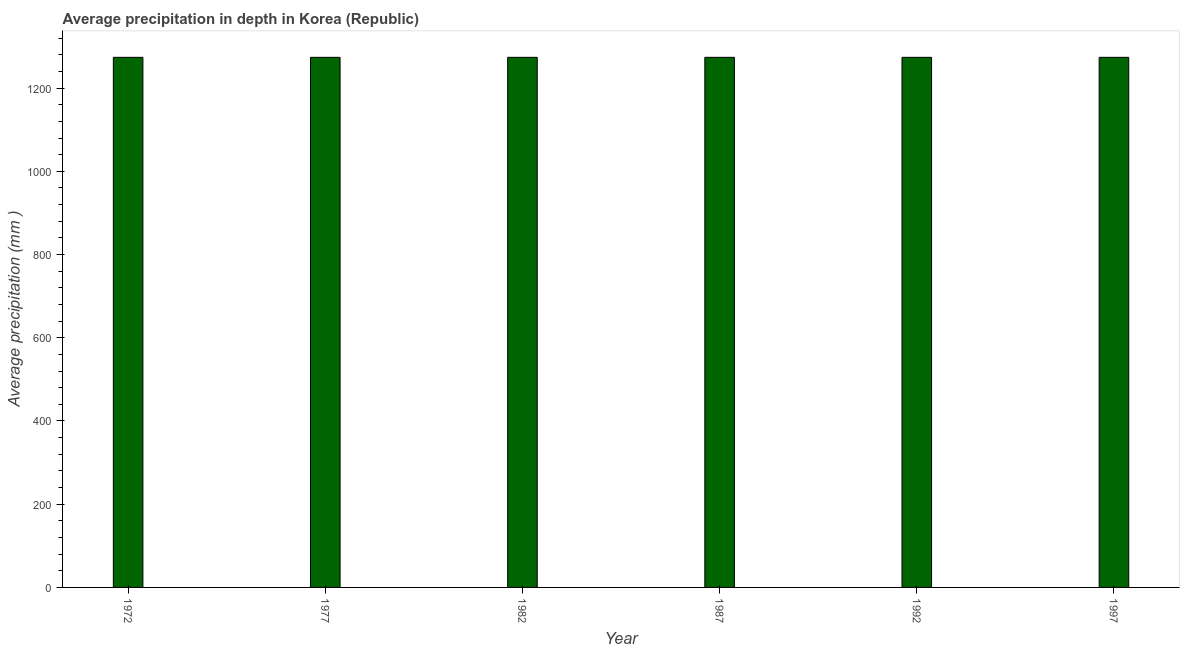Does the graph contain any zero values?
Keep it short and to the point. No. Does the graph contain grids?
Provide a short and direct response. No. What is the title of the graph?
Provide a short and direct response. Average precipitation in depth in Korea (Republic). What is the label or title of the Y-axis?
Offer a very short reply. Average precipitation (mm ). What is the average precipitation in depth in 1977?
Your answer should be compact. 1274. Across all years, what is the maximum average precipitation in depth?
Your answer should be very brief. 1274. Across all years, what is the minimum average precipitation in depth?
Offer a very short reply. 1274. In which year was the average precipitation in depth maximum?
Offer a terse response. 1972. In which year was the average precipitation in depth minimum?
Your answer should be compact. 1972. What is the sum of the average precipitation in depth?
Give a very brief answer. 7644. What is the difference between the average precipitation in depth in 1977 and 1992?
Your answer should be very brief. 0. What is the average average precipitation in depth per year?
Give a very brief answer. 1274. What is the median average precipitation in depth?
Keep it short and to the point. 1274. Is the difference between the average precipitation in depth in 1977 and 1982 greater than the difference between any two years?
Make the answer very short. Yes. What is the difference between the highest and the lowest average precipitation in depth?
Offer a terse response. 0. Are all the bars in the graph horizontal?
Provide a succinct answer. No. How many years are there in the graph?
Make the answer very short. 6. What is the Average precipitation (mm ) of 1972?
Ensure brevity in your answer.  1274. What is the Average precipitation (mm ) in 1977?
Provide a succinct answer. 1274. What is the Average precipitation (mm ) of 1982?
Your response must be concise. 1274. What is the Average precipitation (mm ) of 1987?
Your answer should be very brief. 1274. What is the Average precipitation (mm ) of 1992?
Offer a terse response. 1274. What is the Average precipitation (mm ) in 1997?
Make the answer very short. 1274. What is the difference between the Average precipitation (mm ) in 1972 and 1977?
Ensure brevity in your answer.  0. What is the difference between the Average precipitation (mm ) in 1972 and 1982?
Offer a very short reply. 0. What is the difference between the Average precipitation (mm ) in 1972 and 1992?
Ensure brevity in your answer.  0. What is the difference between the Average precipitation (mm ) in 1977 and 1997?
Offer a terse response. 0. What is the difference between the Average precipitation (mm ) in 1982 and 1992?
Keep it short and to the point. 0. What is the difference between the Average precipitation (mm ) in 1982 and 1997?
Offer a very short reply. 0. What is the difference between the Average precipitation (mm ) in 1987 and 1997?
Your answer should be very brief. 0. What is the difference between the Average precipitation (mm ) in 1992 and 1997?
Your response must be concise. 0. What is the ratio of the Average precipitation (mm ) in 1972 to that in 1977?
Your answer should be very brief. 1. What is the ratio of the Average precipitation (mm ) in 1972 to that in 1992?
Give a very brief answer. 1. What is the ratio of the Average precipitation (mm ) in 1977 to that in 1982?
Provide a short and direct response. 1. What is the ratio of the Average precipitation (mm ) in 1977 to that in 1987?
Ensure brevity in your answer.  1. What is the ratio of the Average precipitation (mm ) in 1982 to that in 1987?
Provide a short and direct response. 1. What is the ratio of the Average precipitation (mm ) in 1987 to that in 1997?
Your response must be concise. 1. 